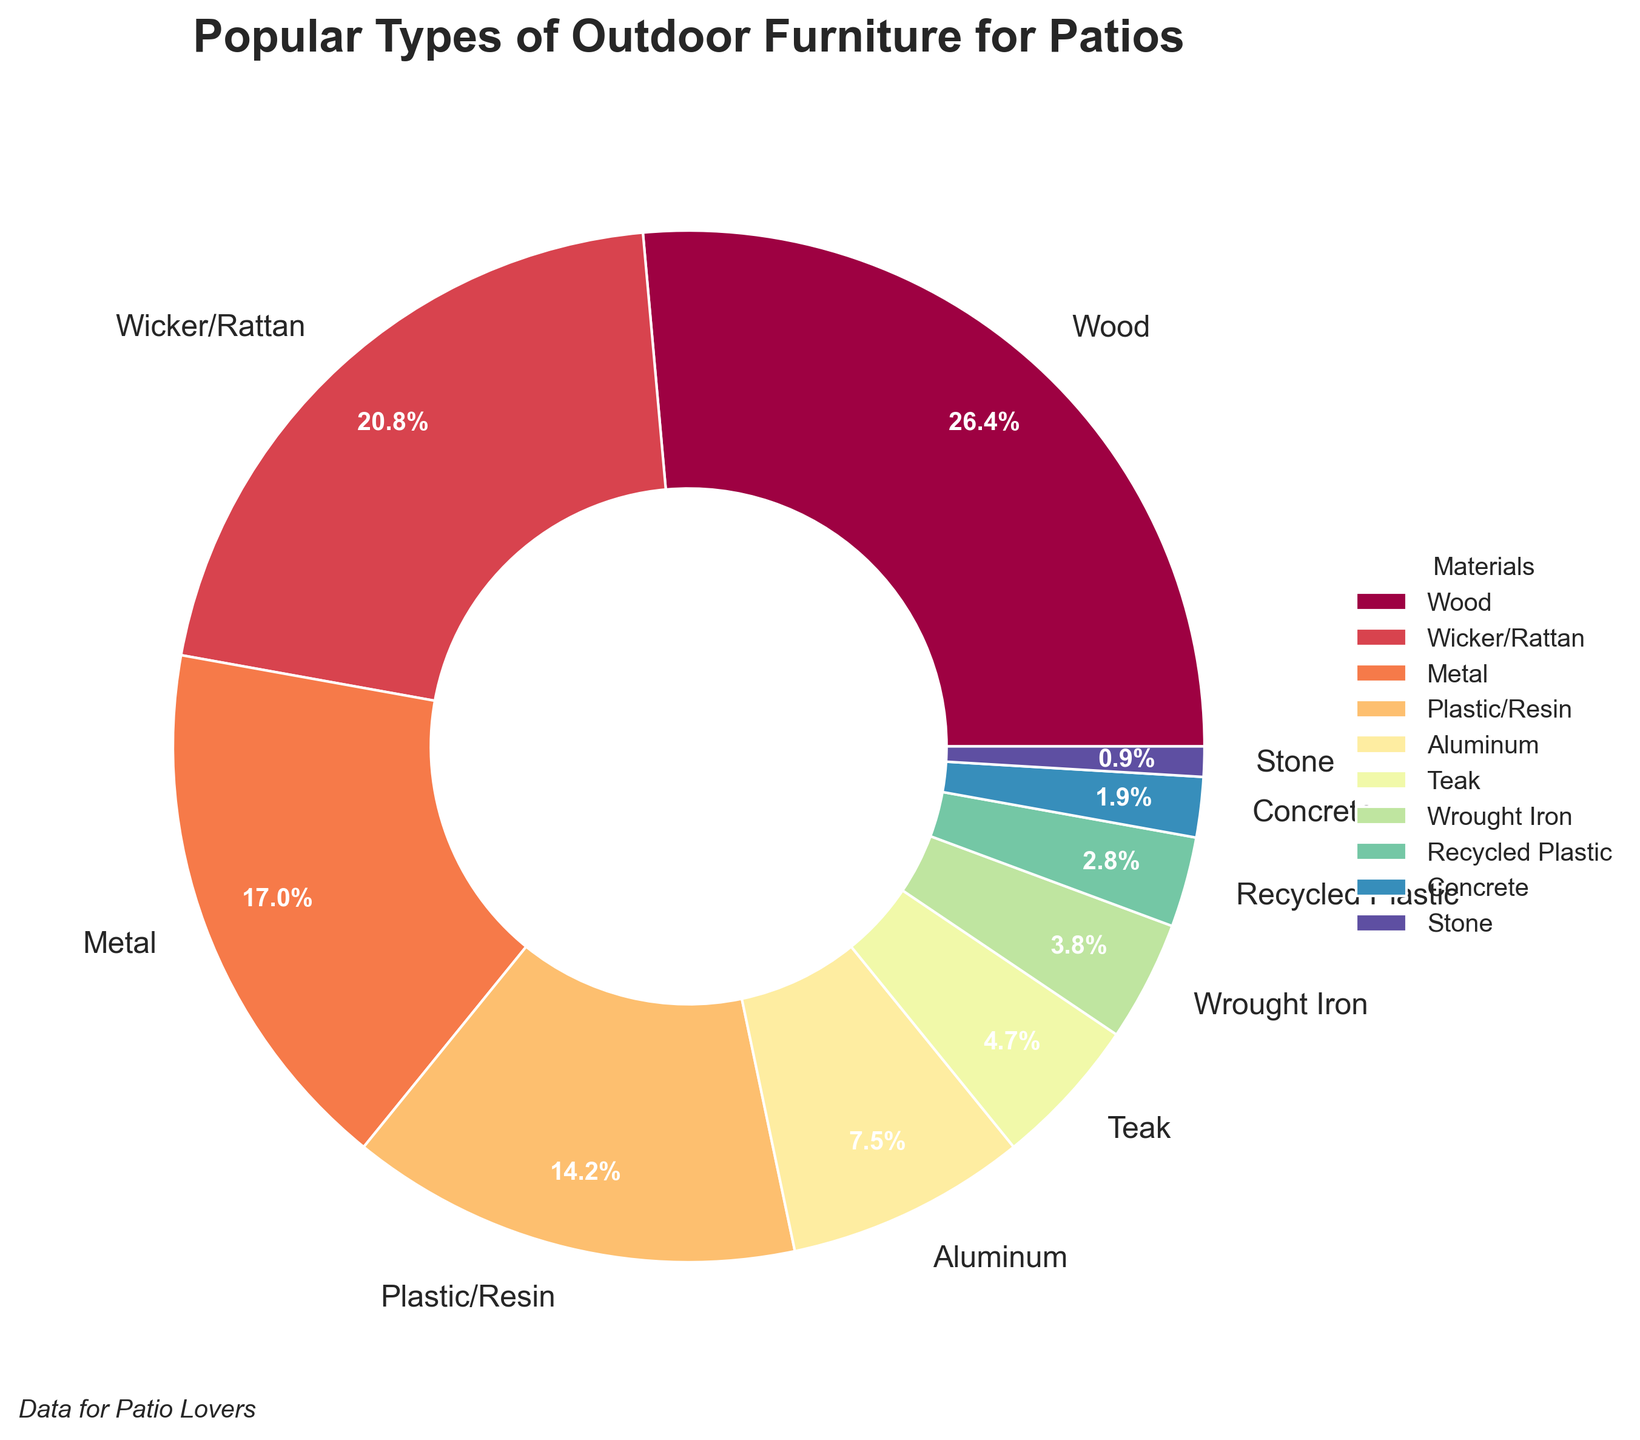What's the most popular type of outdoor furniture material? The largest segment in the pie chart represents the most popular type of outdoor furniture material, which is Wood with the highest percentage.
Answer: Wood What's the least popular type of outdoor furniture material? The smallest segment in the pie chart represents the least popular type of outdoor furniture material, which is Stone with the smallest percentage.
Answer: Stone Which material is more popular, Wicker/Rattan or Metal? By comparing the segments for Wicker/Rattan and Metal, Wicker/Rattan is greater with 22% while Metal is 18%.
Answer: Wicker/Rattan What's the combined percentage of Wood and Teak materials? To find the combined percentage, add the percentages of Wood and Teak. Wood is 28% and Teak is 5%, so 28 + 5 = 33%.
Answer: 33% How much higher is the percentage of Plastic/Resin compared to Aluminum? Subtract the percentage of Aluminum from Plastic/Resin. Plastic/Resin is 15% and Aluminum is 8%, hence 15 - 8 = 7%.
Answer: 7% Are Wicker/Rattan and Plastic/Resin together more or less popular than Metal and Aluminum together? Calculate the totals for each pair: Wicker/Rattan and Plastic/Resin is 22% + 15% = 37%, while Metal and Aluminum is 18% + 8% = 26%. Compare 37% to 26%.
Answer: More If the combined percentage of Concrete and Recycled Plastic is more than Stone by at least 3%, what will it be? Add the percentages of Concrete and Recycled Plastic, then compare with the percentage of Stone. Concrete is 2% and Recycled Plastic is 3%, so 2 + 3 = 5%. Stone is 1%. The combined percentage needs to be evaluated: 5 > 1 + 3, hence 5 > 4.
Answer: 5% Which three materials appear to encompass over half of the market share? Adding percentages of the top three materials to see if it exceeds 50%: Wood (28%), Wicker/Rattan (22%), and Metal (18%). 28 + 22 + 18 = 68% which is over half.
Answer: Wood, Wicker/Rattan, Metal Do Metal and Aluminum together constitute a larger percentage than Wicker/Rattan? Adding percentages: Metal is 18% and Aluminum is 8%, so 18 + 8 = 26%. Compare this with Wicker/Rattan's percentage which is 22%.
Answer: Yes How does the popularity of Aluminum compare to Wrought Iron? Compare the percentages of Aluminum and Wrought Iron. Aluminum has 8% while Wrought Iron has 4%, making Aluminum twice as popular.
Answer: Aluminum is twice as popular as Wrought Iron 